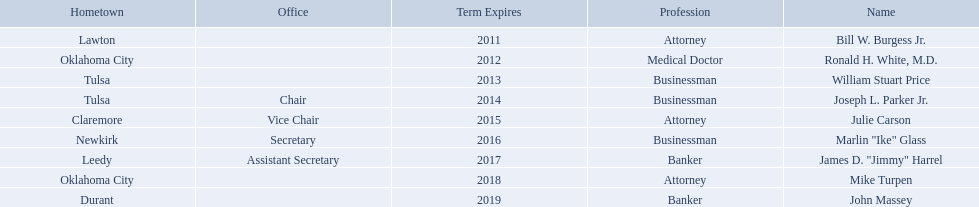Who are the regents? Bill W. Burgess Jr., Ronald H. White, M.D., William Stuart Price, Joseph L. Parker Jr., Julie Carson, Marlin "Ike" Glass, James D. "Jimmy" Harrel, Mike Turpen, John Massey. Of these who is a businessman? William Stuart Price, Joseph L. Parker Jr., Marlin "Ike" Glass. Of these whose hometown is tulsa? William Stuart Price, Joseph L. Parker Jr. Of these whose term expires in 2013? William Stuart Price. 